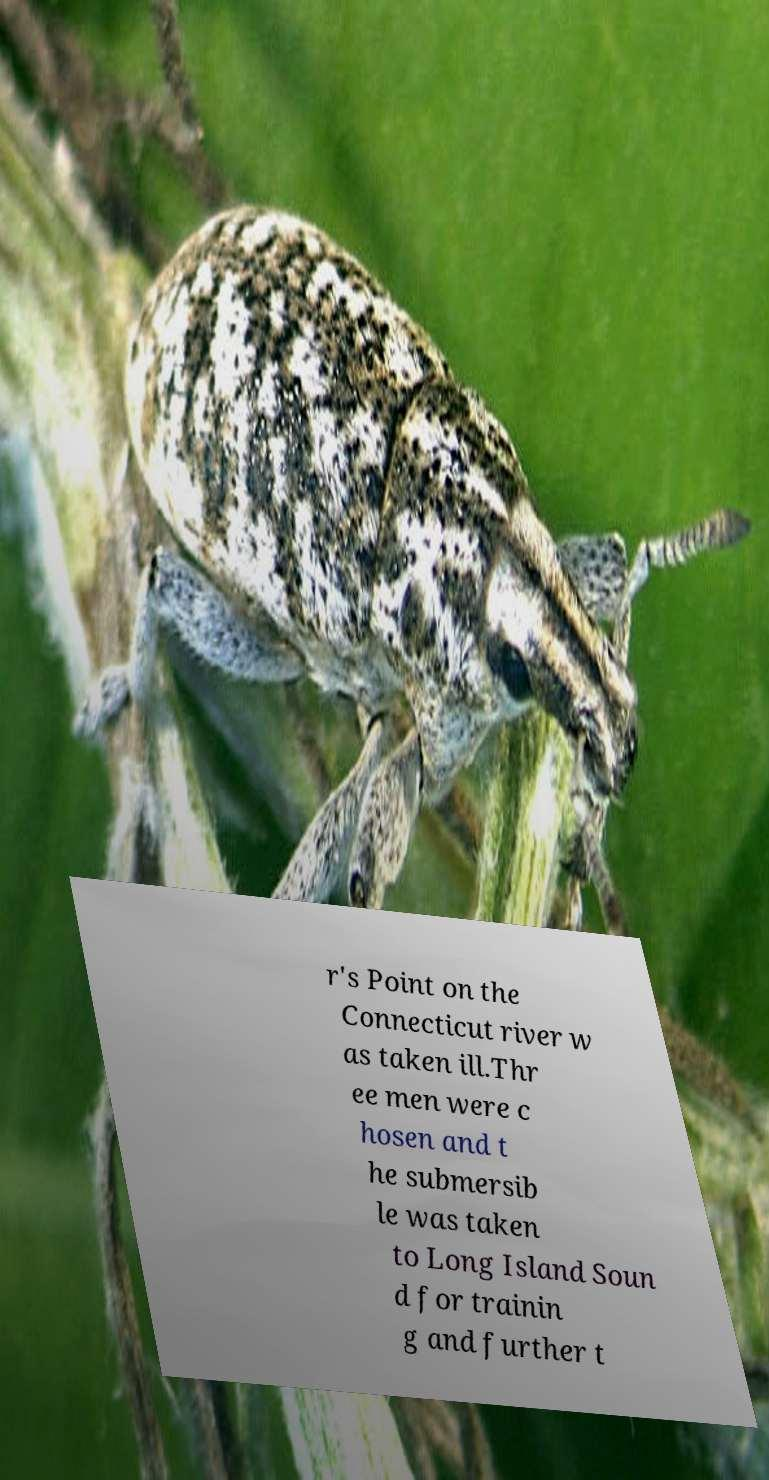Please read and relay the text visible in this image. What does it say? r's Point on the Connecticut river w as taken ill.Thr ee men were c hosen and t he submersib le was taken to Long Island Soun d for trainin g and further t 